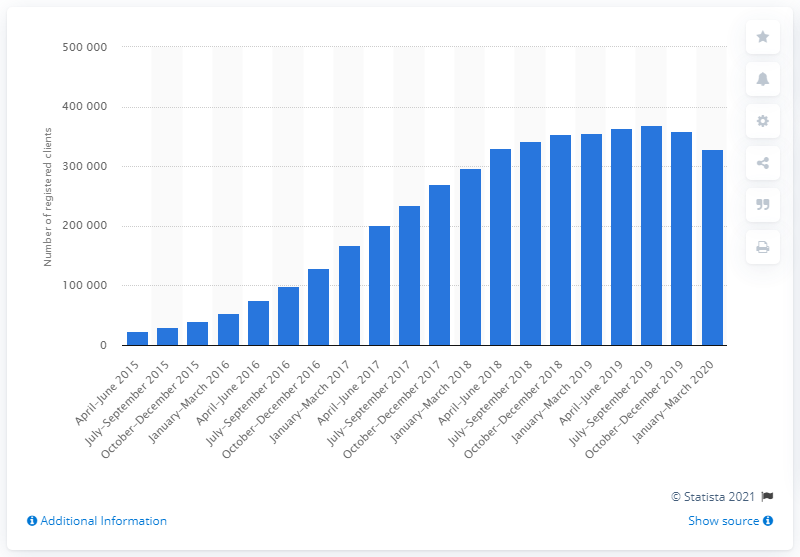Draw attention to some important aspects in this diagram. At the end of April-June 2019, there were 363,917 registered medical marijuana clients in Canada. 